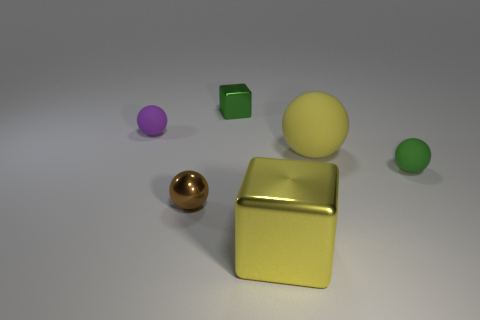Is there anything else that is made of the same material as the green block?
Offer a terse response. Yes. What size is the yellow thing that is made of the same material as the green sphere?
Your answer should be compact. Large. There is a purple ball that is behind the yellow thing that is to the right of the large yellow object that is in front of the tiny green sphere; what size is it?
Provide a short and direct response. Small. How big is the block behind the small brown ball?
Your answer should be compact. Small. How many green things are either small metal cubes or big matte spheres?
Your answer should be very brief. 1. Are there any purple balls that have the same size as the yellow metallic block?
Make the answer very short. No. What material is the cube that is the same size as the brown metal ball?
Make the answer very short. Metal. There is a green object behind the green rubber ball; is it the same size as the metallic cube to the right of the tiny green metal object?
Offer a terse response. No. What number of things are small green blocks or metallic blocks in front of the green metal cube?
Provide a short and direct response. 2. Are there any small green metallic things that have the same shape as the large metallic thing?
Ensure brevity in your answer.  Yes. 